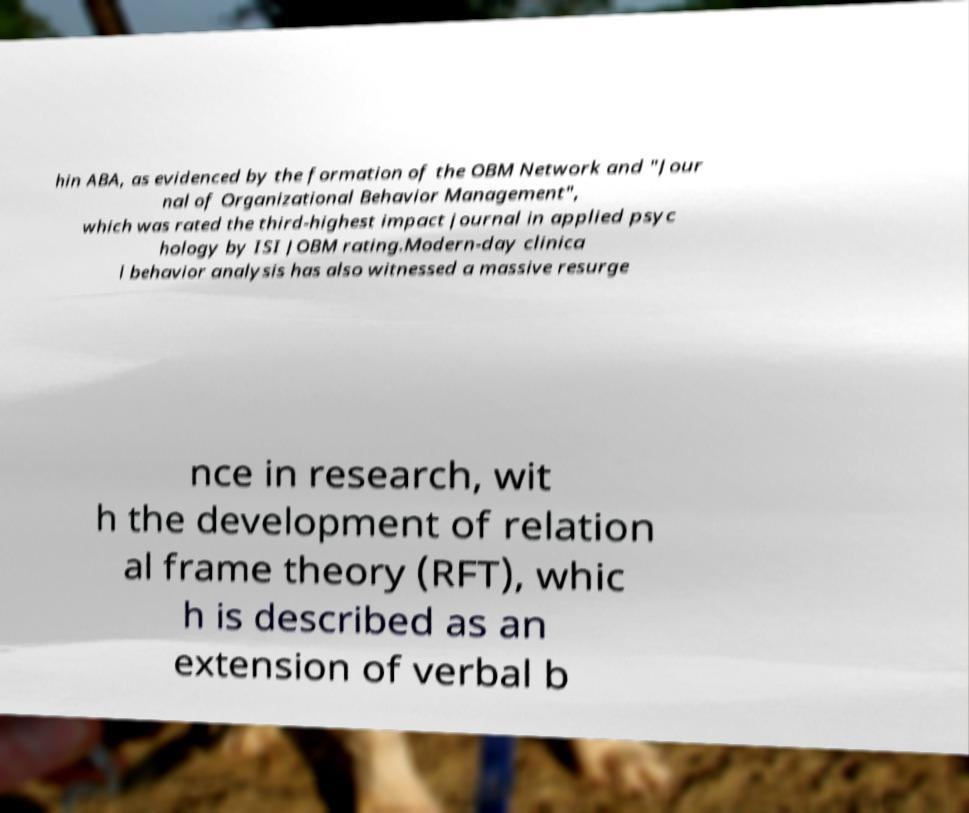Please read and relay the text visible in this image. What does it say? hin ABA, as evidenced by the formation of the OBM Network and "Jour nal of Organizational Behavior Management", which was rated the third-highest impact journal in applied psyc hology by ISI JOBM rating.Modern-day clinica l behavior analysis has also witnessed a massive resurge nce in research, wit h the development of relation al frame theory (RFT), whic h is described as an extension of verbal b 